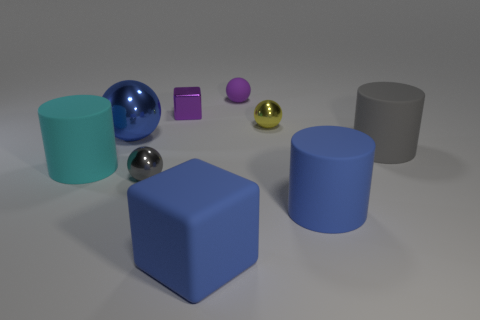Subtract all large metal spheres. How many spheres are left? 3 Subtract all cyan cylinders. How many cylinders are left? 2 Subtract all cylinders. How many objects are left? 6 Subtract 1 spheres. How many spheres are left? 3 Subtract all gray rubber things. Subtract all tiny yellow shiny spheres. How many objects are left? 7 Add 9 tiny gray metallic balls. How many tiny gray metallic balls are left? 10 Add 7 tiny purple shiny blocks. How many tiny purple shiny blocks exist? 8 Subtract 0 brown cylinders. How many objects are left? 9 Subtract all red cylinders. Subtract all blue spheres. How many cylinders are left? 3 